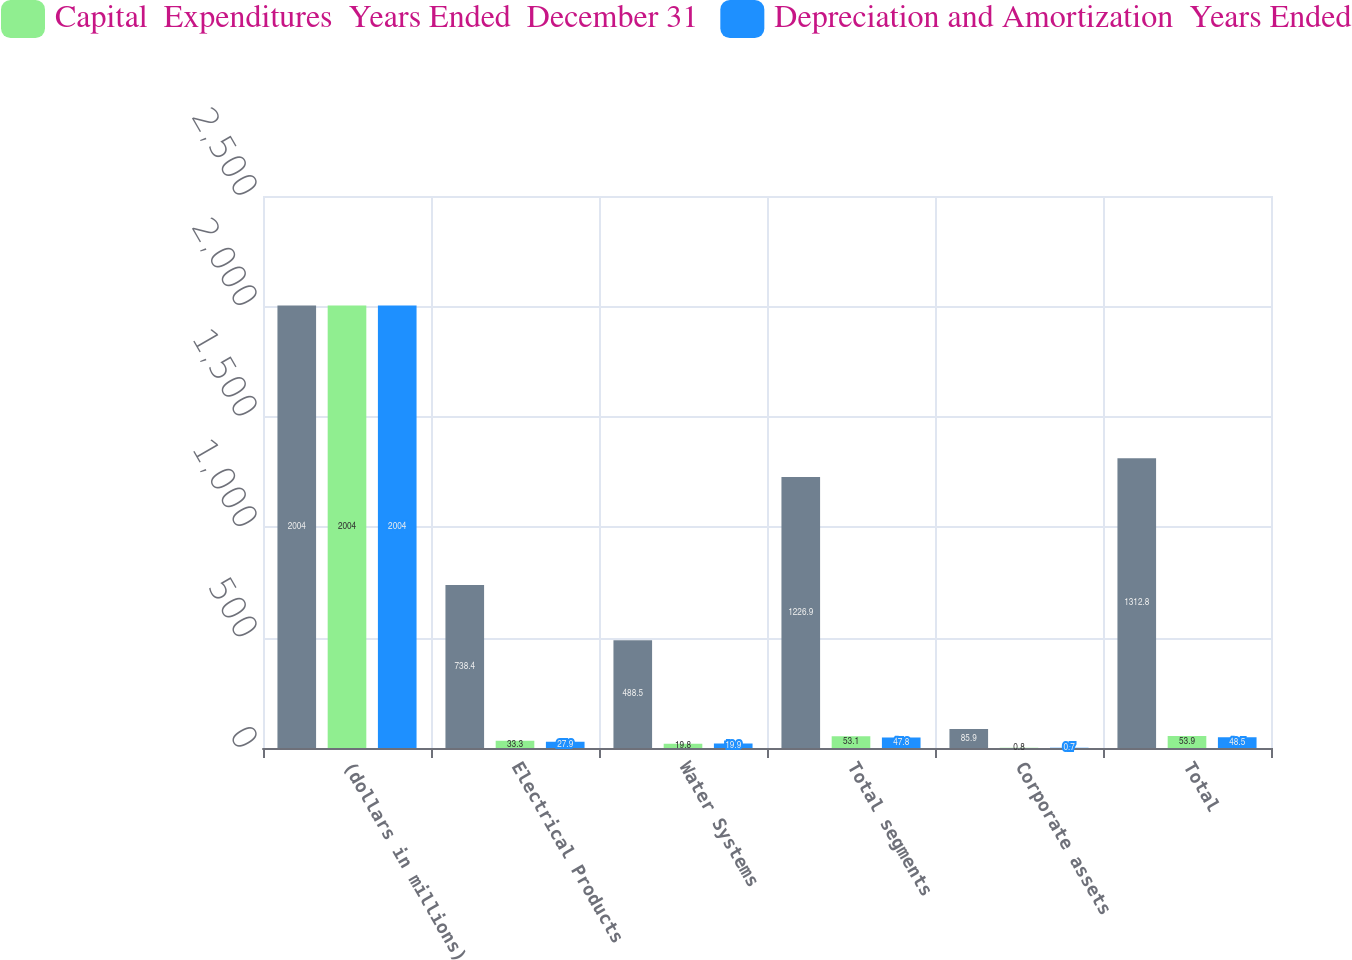Convert chart. <chart><loc_0><loc_0><loc_500><loc_500><stacked_bar_chart><ecel><fcel>(dollars in millions)<fcel>Electrical Products<fcel>Water Systems<fcel>Total segments<fcel>Corporate assets<fcel>Total<nl><fcel>nan<fcel>2004<fcel>738.4<fcel>488.5<fcel>1226.9<fcel>85.9<fcel>1312.8<nl><fcel>Capital  Expenditures  Years Ended  December 31<fcel>2004<fcel>33.3<fcel>19.8<fcel>53.1<fcel>0.8<fcel>53.9<nl><fcel>Depreciation and Amortization  Years Ended<fcel>2004<fcel>27.9<fcel>19.9<fcel>47.8<fcel>0.7<fcel>48.5<nl></chart> 